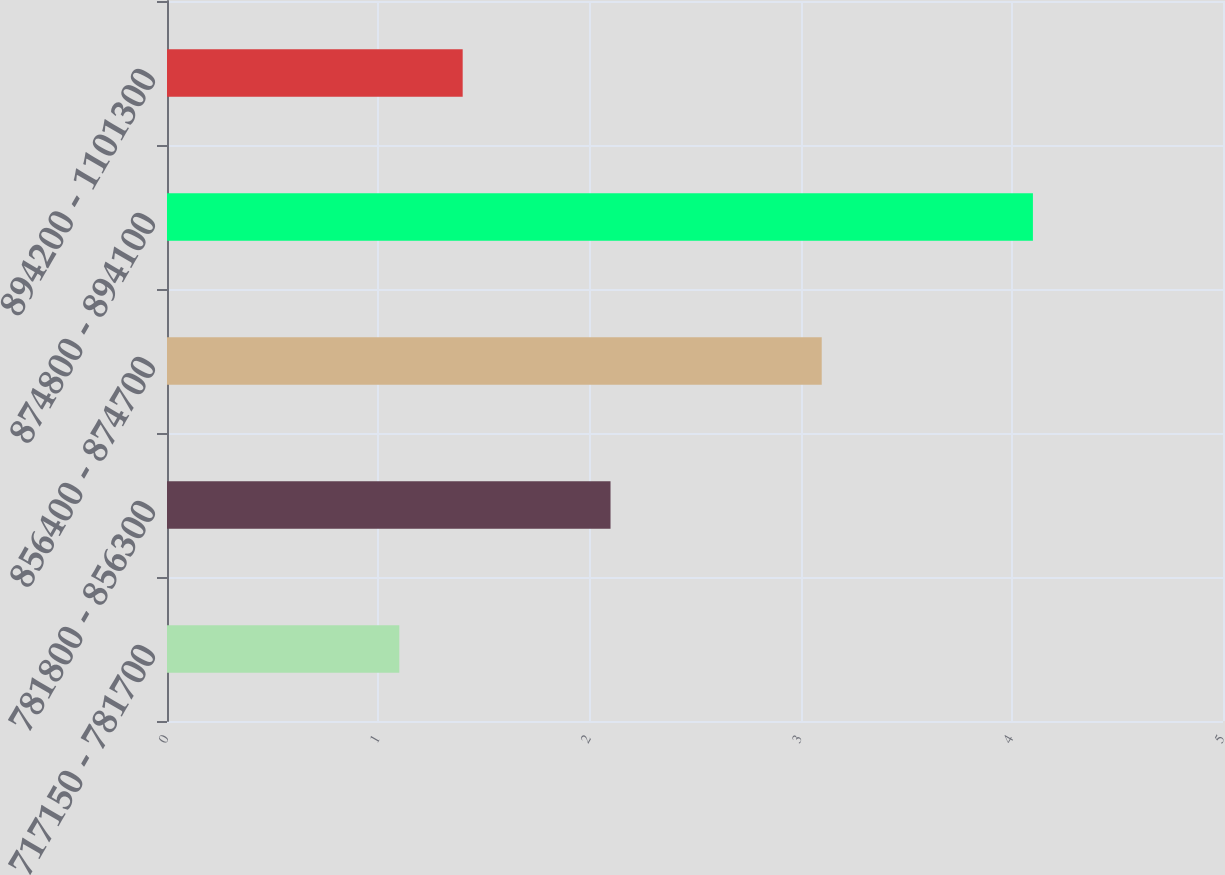Convert chart. <chart><loc_0><loc_0><loc_500><loc_500><bar_chart><fcel>717150 - 781700<fcel>781800 - 856300<fcel>856400 - 874700<fcel>874800 - 894100<fcel>894200 - 1101300<nl><fcel>1.1<fcel>2.1<fcel>3.1<fcel>4.1<fcel>1.4<nl></chart> 